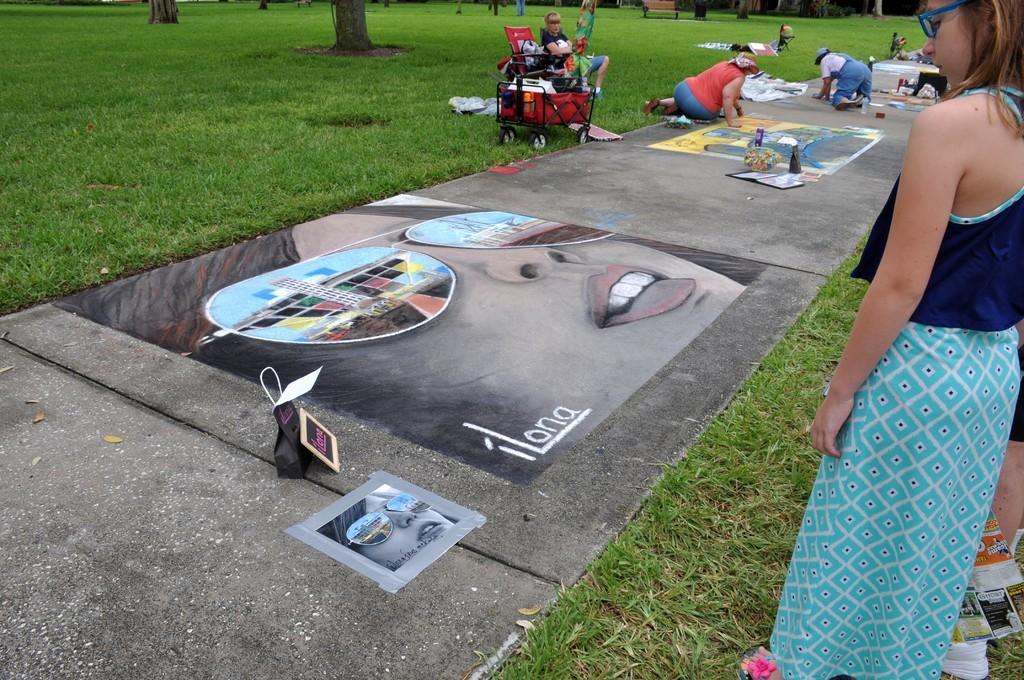Can you describe this image briefly? In this image there are stone slabs on the grassland. There are paintings on the stone slabs. There are bags and few objects on the stone slabs. Bottom of the image there is a photo attached to the stone slab. Right side there are people standing on the grassland. There is a trolley on the grassland having few objects. There is a person sitting on the chair. There are people on the stone slab. Top of the image there is a bench on the grassland having tree trunks. 